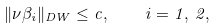Convert formula to latex. <formula><loc_0><loc_0><loc_500><loc_500>\| \nu \beta _ { i } \| _ { \L D W } \leq c , \quad i = 1 , \, 2 ,</formula> 